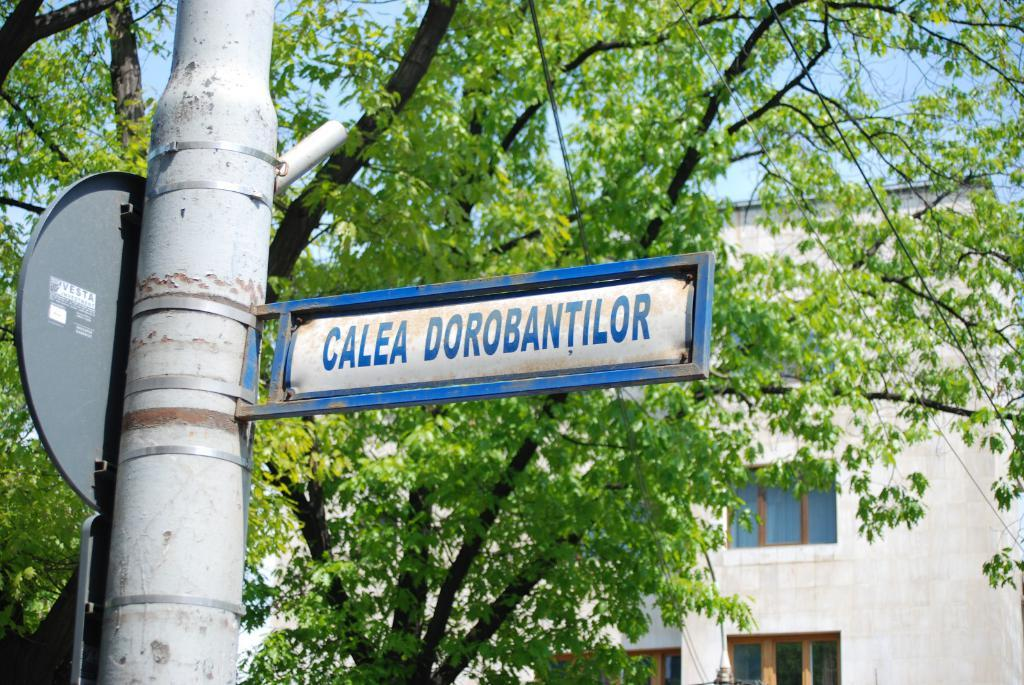Provide a one-sentence caption for the provided image. Sign that says Calea Dorobantilor in blue and white. 